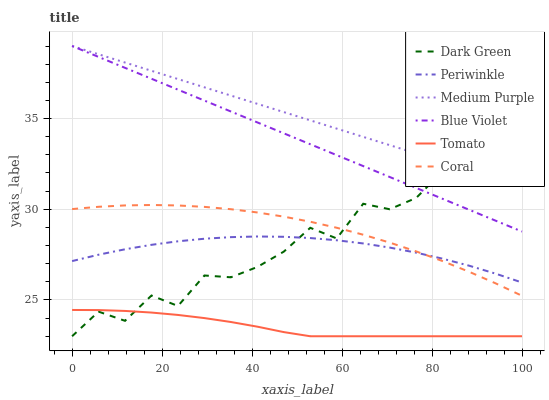Does Coral have the minimum area under the curve?
Answer yes or no. No. Does Coral have the maximum area under the curve?
Answer yes or no. No. Is Coral the smoothest?
Answer yes or no. No. Is Coral the roughest?
Answer yes or no. No. Does Coral have the lowest value?
Answer yes or no. No. Does Coral have the highest value?
Answer yes or no. No. Is Tomato less than Periwinkle?
Answer yes or no. Yes. Is Periwinkle greater than Tomato?
Answer yes or no. Yes. Does Tomato intersect Periwinkle?
Answer yes or no. No. 